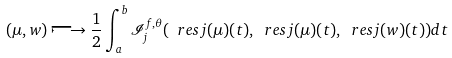Convert formula to latex. <formula><loc_0><loc_0><loc_500><loc_500>( \mu , w ) \longmapsto \frac { 1 } { 2 } \int _ { a } ^ { b } \mathcal { I } _ { j } ^ { f , \theta } ( \ r e s j ( \mu ) ( t ) , \ r e s j ( \mu ) ( t ) , \ r e s j ( w ) ( t ) ) d t</formula> 